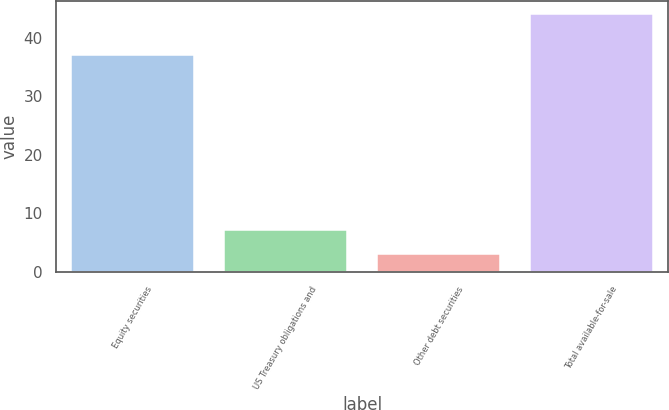Convert chart to OTSL. <chart><loc_0><loc_0><loc_500><loc_500><bar_chart><fcel>Equity securities<fcel>US Treasury obligations and<fcel>Other debt securities<fcel>Total available-for-sale<nl><fcel>37<fcel>7.1<fcel>3<fcel>44<nl></chart> 